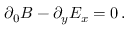Convert formula to latex. <formula><loc_0><loc_0><loc_500><loc_500>\partial _ { 0 } B - \partial _ { y } E _ { x } = 0 \, .</formula> 